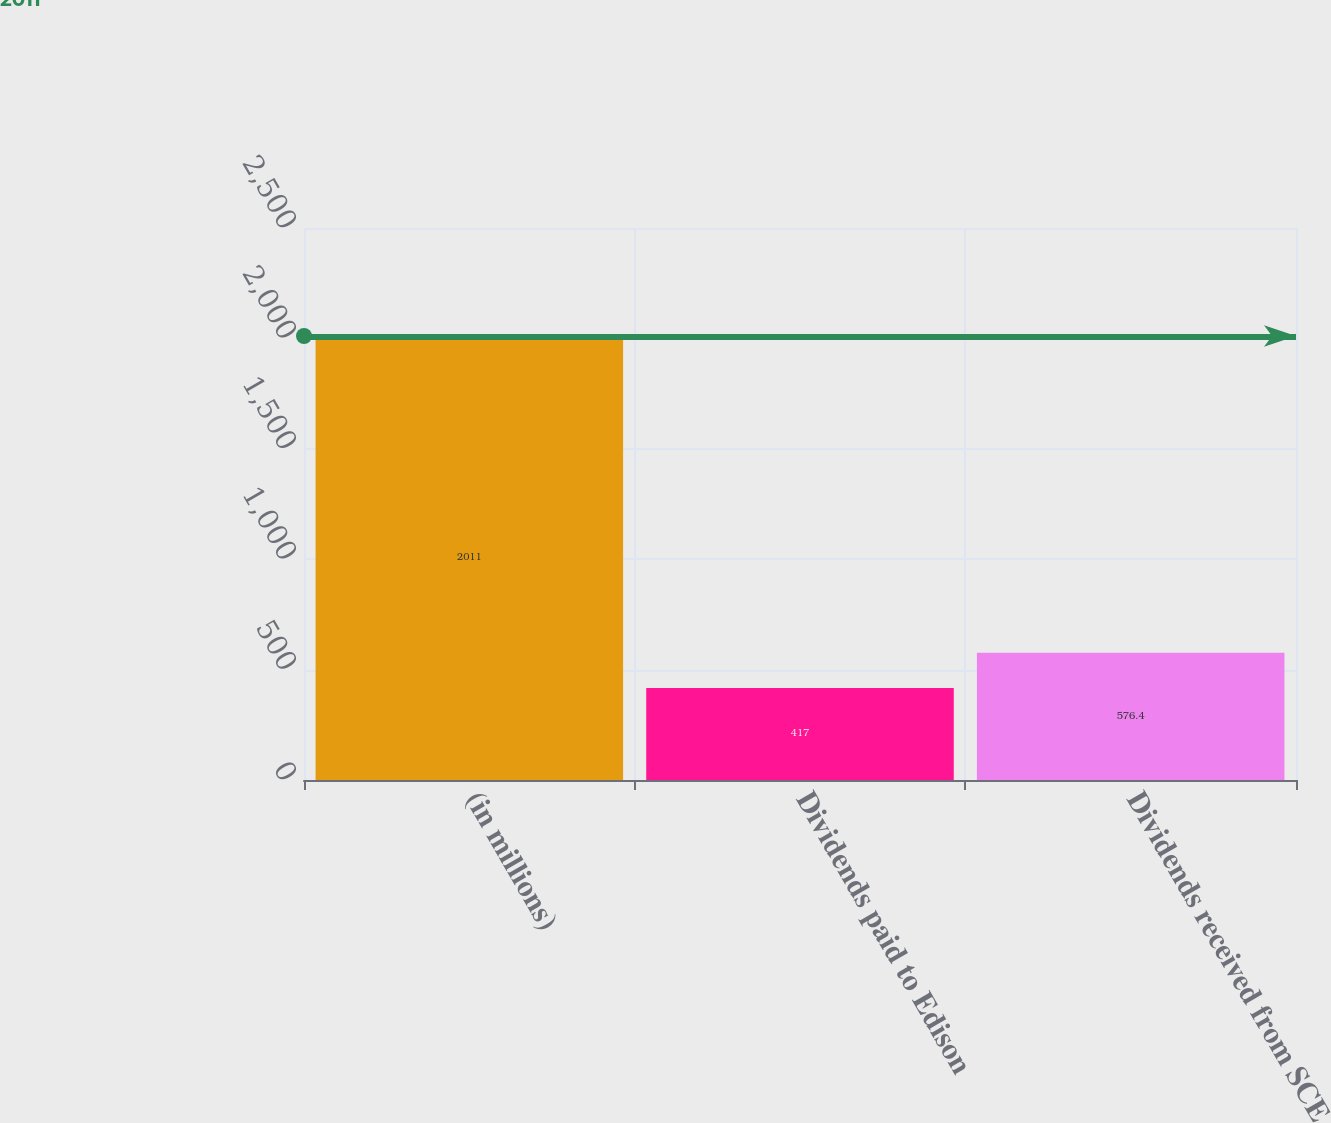Convert chart. <chart><loc_0><loc_0><loc_500><loc_500><bar_chart><fcel>(in millions)<fcel>Dividends paid to Edison<fcel>Dividends received from SCE<nl><fcel>2011<fcel>417<fcel>576.4<nl></chart> 